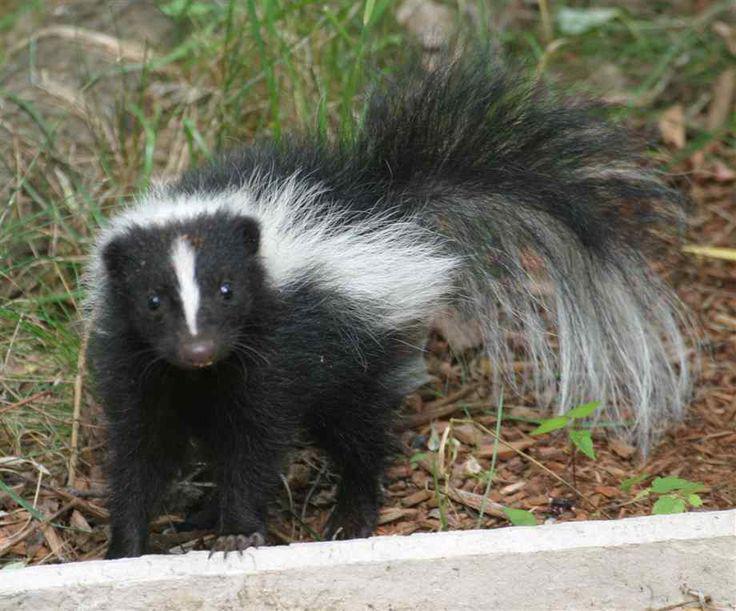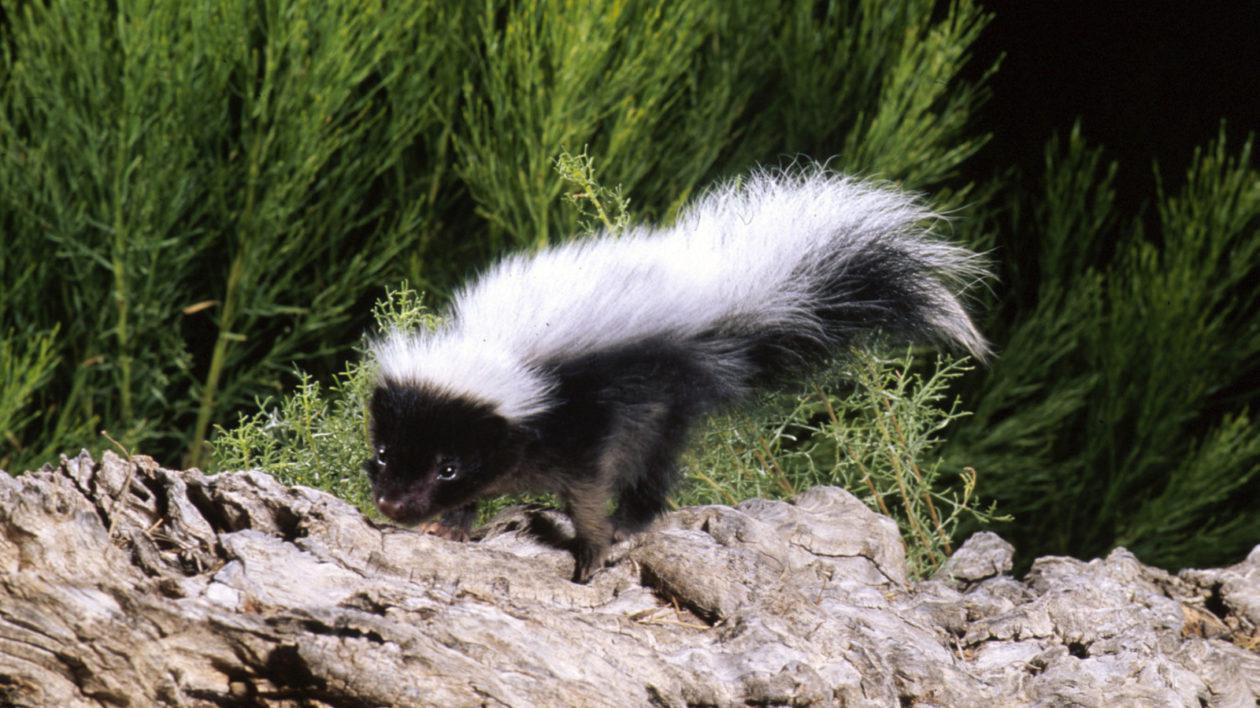The first image is the image on the left, the second image is the image on the right. Given the left and right images, does the statement "One of the images has a skunk along with a an animal that is not a skunk." hold true? Answer yes or no. No. The first image is the image on the left, the second image is the image on the right. Given the left and right images, does the statement "In one of the images an animal can be seen eating dog food." hold true? Answer yes or no. No. 